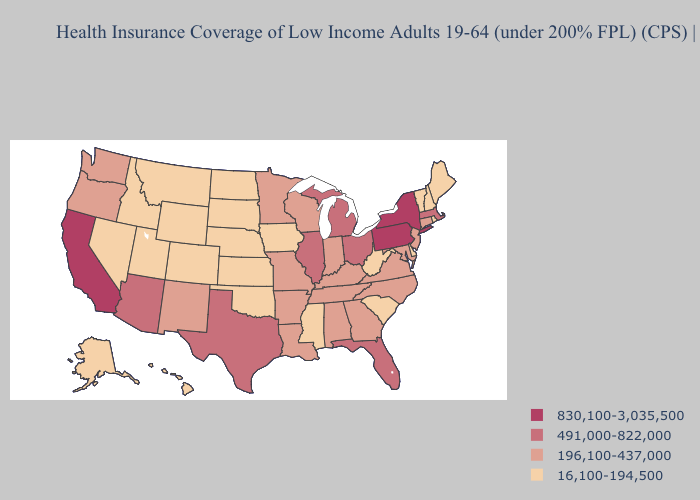Does the map have missing data?
Keep it brief. No. What is the lowest value in the Northeast?
Concise answer only. 16,100-194,500. Does Washington have a lower value than New Hampshire?
Answer briefly. No. Name the states that have a value in the range 16,100-194,500?
Concise answer only. Alaska, Colorado, Delaware, Hawaii, Idaho, Iowa, Kansas, Maine, Mississippi, Montana, Nebraska, Nevada, New Hampshire, North Dakota, Oklahoma, Rhode Island, South Carolina, South Dakota, Utah, Vermont, West Virginia, Wyoming. Name the states that have a value in the range 830,100-3,035,500?
Keep it brief. California, New York, Pennsylvania. Which states have the lowest value in the Northeast?
Give a very brief answer. Maine, New Hampshire, Rhode Island, Vermont. Which states have the lowest value in the West?
Keep it brief. Alaska, Colorado, Hawaii, Idaho, Montana, Nevada, Utah, Wyoming. Name the states that have a value in the range 196,100-437,000?
Concise answer only. Alabama, Arkansas, Connecticut, Georgia, Indiana, Kentucky, Louisiana, Maryland, Minnesota, Missouri, New Jersey, New Mexico, North Carolina, Oregon, Tennessee, Virginia, Washington, Wisconsin. Name the states that have a value in the range 830,100-3,035,500?
Write a very short answer. California, New York, Pennsylvania. Name the states that have a value in the range 491,000-822,000?
Write a very short answer. Arizona, Florida, Illinois, Massachusetts, Michigan, Ohio, Texas. Name the states that have a value in the range 16,100-194,500?
Give a very brief answer. Alaska, Colorado, Delaware, Hawaii, Idaho, Iowa, Kansas, Maine, Mississippi, Montana, Nebraska, Nevada, New Hampshire, North Dakota, Oklahoma, Rhode Island, South Carolina, South Dakota, Utah, Vermont, West Virginia, Wyoming. What is the value of Utah?
Give a very brief answer. 16,100-194,500. Among the states that border Idaho , does Montana have the highest value?
Write a very short answer. No. Does South Dakota have the highest value in the MidWest?
Quick response, please. No. Which states have the highest value in the USA?
Keep it brief. California, New York, Pennsylvania. 